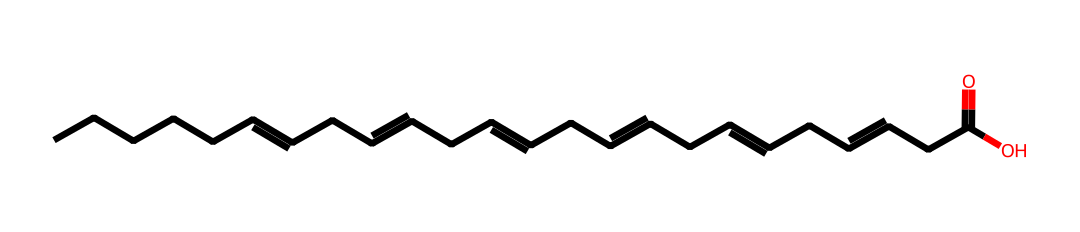What is the total number of carbon atoms in the molecule? Counting the carbon atoms from the SMILES notation shows there are a total of 22 carbon atoms, indicated by the presence of "C" without numerical prefixes.
Answer: 22 How many double bonds are present in docosahexaenoic acid? By examining the SMILES, we notice the "=" symbols indicating double bonds. There are 6 double bonds shown in the structure.
Answer: 6 What functional group is present in DHA? The presence of "COOH" in the SMILES notation indicates a carboxylic acid functional group at the end of the carbon chain.
Answer: carboxylic acid What is the degree of unsaturation in this molecule? The degree of unsaturation can be determined by using the formula: (2C + 2 + N - H - X) / 2. For DHA, with 22 carbons and 6 double bonds, it results in a degree of 6.
Answer: 6 What type of fatty acid is docosahexaenoic acid classified as? Given its structure features multiple double bonds and long carbon chains, it is classified as a polyunsaturated fatty acid.
Answer: polyunsaturated fatty acid How many hydrogen atoms are bonded to the structure? The hydrogen count can be inferred by deducing from the formula for carbon chain length and double bonds. In DHA with 22 carbons and 6 double bonds, there are 32 hydrogen atoms.
Answer: 32 